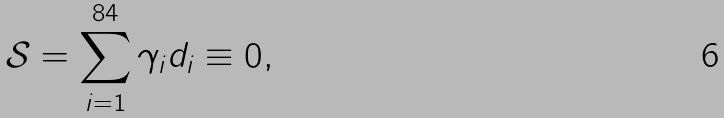Convert formula to latex. <formula><loc_0><loc_0><loc_500><loc_500>\mathcal { S } = \sum _ { i = 1 } ^ { 8 4 } \gamma _ { i } d _ { i } \equiv 0 ,</formula> 